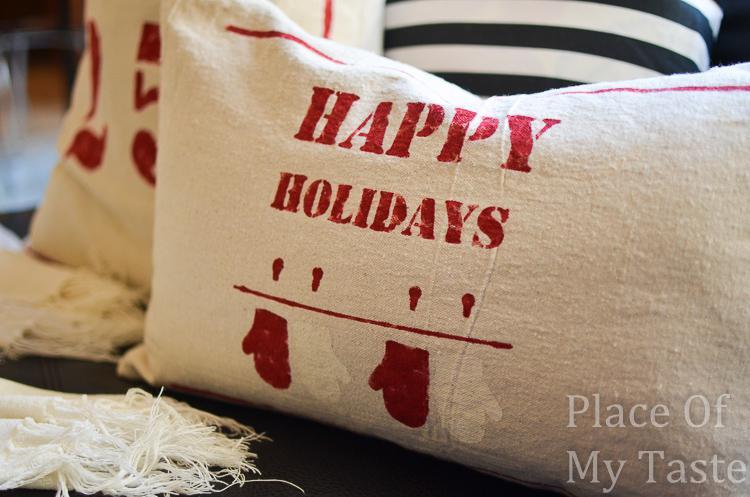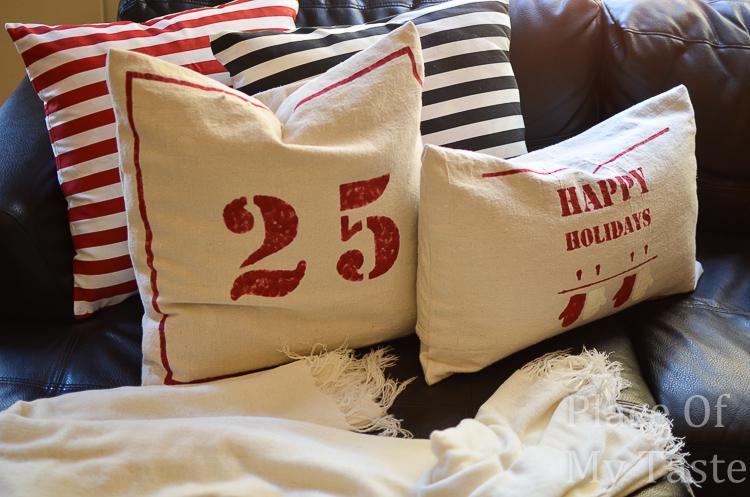The first image is the image on the left, the second image is the image on the right. For the images displayed, is the sentence "All images include at least one pillow with text on it, and one image also includes two striped pillows." factually correct? Answer yes or no. Yes. The first image is the image on the left, the second image is the image on the right. Analyze the images presented: Is the assertion "There are at least 7 pillows." valid? Answer yes or no. Yes. 